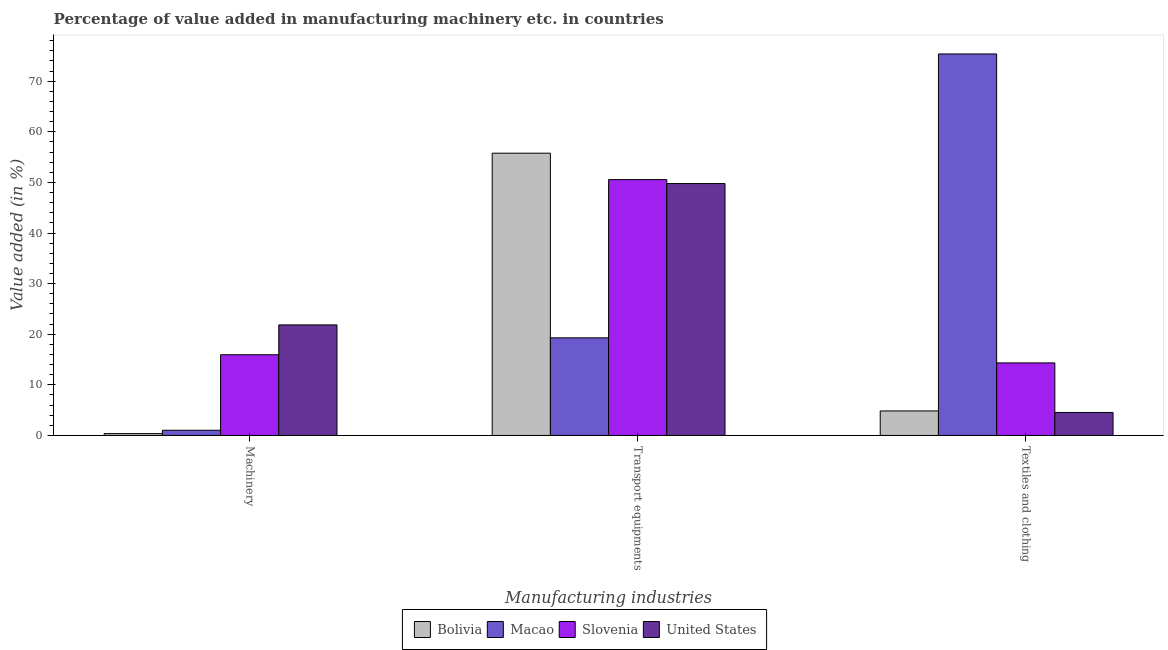How many different coloured bars are there?
Offer a very short reply. 4. How many groups of bars are there?
Your answer should be compact. 3. What is the label of the 1st group of bars from the left?
Your answer should be very brief. Machinery. What is the value added in manufacturing transport equipments in Macao?
Provide a short and direct response. 19.28. Across all countries, what is the maximum value added in manufacturing machinery?
Your response must be concise. 21.84. Across all countries, what is the minimum value added in manufacturing machinery?
Offer a terse response. 0.36. In which country was the value added in manufacturing textile and clothing maximum?
Offer a very short reply. Macao. In which country was the value added in manufacturing transport equipments minimum?
Give a very brief answer. Macao. What is the total value added in manufacturing transport equipments in the graph?
Provide a short and direct response. 175.39. What is the difference between the value added in manufacturing machinery in United States and that in Macao?
Give a very brief answer. 20.81. What is the difference between the value added in manufacturing transport equipments in United States and the value added in manufacturing textile and clothing in Macao?
Keep it short and to the point. -25.61. What is the average value added in manufacturing textile and clothing per country?
Ensure brevity in your answer.  24.78. What is the difference between the value added in manufacturing machinery and value added in manufacturing transport equipments in Macao?
Your response must be concise. -18.26. In how many countries, is the value added in manufacturing textile and clothing greater than 54 %?
Your answer should be compact. 1. What is the ratio of the value added in manufacturing transport equipments in Bolivia to that in Slovenia?
Ensure brevity in your answer.  1.1. Is the difference between the value added in manufacturing machinery in Bolivia and United States greater than the difference between the value added in manufacturing textile and clothing in Bolivia and United States?
Your response must be concise. No. What is the difference between the highest and the second highest value added in manufacturing machinery?
Keep it short and to the point. 5.9. What is the difference between the highest and the lowest value added in manufacturing machinery?
Offer a very short reply. 21.48. Is the sum of the value added in manufacturing textile and clothing in Slovenia and United States greater than the maximum value added in manufacturing machinery across all countries?
Make the answer very short. No. What does the 3rd bar from the left in Textiles and clothing represents?
Your answer should be very brief. Slovenia. What does the 3rd bar from the right in Machinery represents?
Provide a short and direct response. Macao. Is it the case that in every country, the sum of the value added in manufacturing machinery and value added in manufacturing transport equipments is greater than the value added in manufacturing textile and clothing?
Offer a very short reply. No. How many bars are there?
Your answer should be compact. 12. Are all the bars in the graph horizontal?
Make the answer very short. No. What is the difference between two consecutive major ticks on the Y-axis?
Your response must be concise. 10. Are the values on the major ticks of Y-axis written in scientific E-notation?
Your response must be concise. No. Does the graph contain any zero values?
Your answer should be very brief. No. How many legend labels are there?
Make the answer very short. 4. What is the title of the graph?
Ensure brevity in your answer.  Percentage of value added in manufacturing machinery etc. in countries. What is the label or title of the X-axis?
Keep it short and to the point. Manufacturing industries. What is the label or title of the Y-axis?
Ensure brevity in your answer.  Value added (in %). What is the Value added (in %) in Bolivia in Machinery?
Give a very brief answer. 0.36. What is the Value added (in %) in Macao in Machinery?
Offer a very short reply. 1.03. What is the Value added (in %) of Slovenia in Machinery?
Ensure brevity in your answer.  15.94. What is the Value added (in %) of United States in Machinery?
Your answer should be compact. 21.84. What is the Value added (in %) in Bolivia in Transport equipments?
Offer a terse response. 55.77. What is the Value added (in %) in Macao in Transport equipments?
Provide a succinct answer. 19.28. What is the Value added (in %) in Slovenia in Transport equipments?
Your response must be concise. 50.55. What is the Value added (in %) in United States in Transport equipments?
Keep it short and to the point. 49.77. What is the Value added (in %) in Bolivia in Textiles and clothing?
Your answer should be compact. 4.84. What is the Value added (in %) in Macao in Textiles and clothing?
Give a very brief answer. 75.38. What is the Value added (in %) of Slovenia in Textiles and clothing?
Give a very brief answer. 14.33. What is the Value added (in %) in United States in Textiles and clothing?
Offer a very short reply. 4.54. Across all Manufacturing industries, what is the maximum Value added (in %) in Bolivia?
Your response must be concise. 55.77. Across all Manufacturing industries, what is the maximum Value added (in %) of Macao?
Provide a short and direct response. 75.38. Across all Manufacturing industries, what is the maximum Value added (in %) in Slovenia?
Provide a succinct answer. 50.55. Across all Manufacturing industries, what is the maximum Value added (in %) in United States?
Your response must be concise. 49.77. Across all Manufacturing industries, what is the minimum Value added (in %) of Bolivia?
Offer a terse response. 0.36. Across all Manufacturing industries, what is the minimum Value added (in %) in Macao?
Ensure brevity in your answer.  1.03. Across all Manufacturing industries, what is the minimum Value added (in %) of Slovenia?
Your response must be concise. 14.33. Across all Manufacturing industries, what is the minimum Value added (in %) of United States?
Keep it short and to the point. 4.54. What is the total Value added (in %) in Bolivia in the graph?
Give a very brief answer. 60.98. What is the total Value added (in %) of Macao in the graph?
Provide a succinct answer. 95.7. What is the total Value added (in %) of Slovenia in the graph?
Give a very brief answer. 80.83. What is the total Value added (in %) in United States in the graph?
Your answer should be very brief. 76.16. What is the difference between the Value added (in %) of Bolivia in Machinery and that in Transport equipments?
Provide a succinct answer. -55.41. What is the difference between the Value added (in %) of Macao in Machinery and that in Transport equipments?
Provide a short and direct response. -18.26. What is the difference between the Value added (in %) in Slovenia in Machinery and that in Transport equipments?
Give a very brief answer. -34.61. What is the difference between the Value added (in %) of United States in Machinery and that in Transport equipments?
Keep it short and to the point. -27.93. What is the difference between the Value added (in %) of Bolivia in Machinery and that in Textiles and clothing?
Keep it short and to the point. -4.48. What is the difference between the Value added (in %) of Macao in Machinery and that in Textiles and clothing?
Give a very brief answer. -74.36. What is the difference between the Value added (in %) of Slovenia in Machinery and that in Textiles and clothing?
Provide a short and direct response. 1.61. What is the difference between the Value added (in %) in United States in Machinery and that in Textiles and clothing?
Ensure brevity in your answer.  17.3. What is the difference between the Value added (in %) of Bolivia in Transport equipments and that in Textiles and clothing?
Provide a short and direct response. 50.93. What is the difference between the Value added (in %) of Macao in Transport equipments and that in Textiles and clothing?
Provide a succinct answer. -56.1. What is the difference between the Value added (in %) of Slovenia in Transport equipments and that in Textiles and clothing?
Make the answer very short. 36.22. What is the difference between the Value added (in %) of United States in Transport equipments and that in Textiles and clothing?
Ensure brevity in your answer.  45.23. What is the difference between the Value added (in %) of Bolivia in Machinery and the Value added (in %) of Macao in Transport equipments?
Provide a succinct answer. -18.92. What is the difference between the Value added (in %) in Bolivia in Machinery and the Value added (in %) in Slovenia in Transport equipments?
Offer a very short reply. -50.19. What is the difference between the Value added (in %) of Bolivia in Machinery and the Value added (in %) of United States in Transport equipments?
Offer a terse response. -49.41. What is the difference between the Value added (in %) of Macao in Machinery and the Value added (in %) of Slovenia in Transport equipments?
Make the answer very short. -49.53. What is the difference between the Value added (in %) of Macao in Machinery and the Value added (in %) of United States in Transport equipments?
Offer a very short reply. -48.75. What is the difference between the Value added (in %) in Slovenia in Machinery and the Value added (in %) in United States in Transport equipments?
Offer a terse response. -33.83. What is the difference between the Value added (in %) of Bolivia in Machinery and the Value added (in %) of Macao in Textiles and clothing?
Provide a succinct answer. -75.02. What is the difference between the Value added (in %) in Bolivia in Machinery and the Value added (in %) in Slovenia in Textiles and clothing?
Provide a short and direct response. -13.97. What is the difference between the Value added (in %) in Bolivia in Machinery and the Value added (in %) in United States in Textiles and clothing?
Your answer should be compact. -4.18. What is the difference between the Value added (in %) of Macao in Machinery and the Value added (in %) of Slovenia in Textiles and clothing?
Offer a terse response. -13.31. What is the difference between the Value added (in %) of Macao in Machinery and the Value added (in %) of United States in Textiles and clothing?
Offer a terse response. -3.52. What is the difference between the Value added (in %) in Slovenia in Machinery and the Value added (in %) in United States in Textiles and clothing?
Your answer should be compact. 11.4. What is the difference between the Value added (in %) of Bolivia in Transport equipments and the Value added (in %) of Macao in Textiles and clothing?
Your answer should be very brief. -19.61. What is the difference between the Value added (in %) in Bolivia in Transport equipments and the Value added (in %) in Slovenia in Textiles and clothing?
Your answer should be compact. 41.44. What is the difference between the Value added (in %) of Bolivia in Transport equipments and the Value added (in %) of United States in Textiles and clothing?
Keep it short and to the point. 51.23. What is the difference between the Value added (in %) in Macao in Transport equipments and the Value added (in %) in Slovenia in Textiles and clothing?
Your response must be concise. 4.95. What is the difference between the Value added (in %) of Macao in Transport equipments and the Value added (in %) of United States in Textiles and clothing?
Provide a succinct answer. 14.74. What is the difference between the Value added (in %) of Slovenia in Transport equipments and the Value added (in %) of United States in Textiles and clothing?
Your response must be concise. 46.01. What is the average Value added (in %) in Bolivia per Manufacturing industries?
Offer a terse response. 20.33. What is the average Value added (in %) of Macao per Manufacturing industries?
Offer a very short reply. 31.9. What is the average Value added (in %) of Slovenia per Manufacturing industries?
Provide a short and direct response. 26.94. What is the average Value added (in %) in United States per Manufacturing industries?
Ensure brevity in your answer.  25.39. What is the difference between the Value added (in %) of Bolivia and Value added (in %) of Macao in Machinery?
Provide a short and direct response. -0.66. What is the difference between the Value added (in %) in Bolivia and Value added (in %) in Slovenia in Machinery?
Provide a succinct answer. -15.58. What is the difference between the Value added (in %) in Bolivia and Value added (in %) in United States in Machinery?
Make the answer very short. -21.48. What is the difference between the Value added (in %) in Macao and Value added (in %) in Slovenia in Machinery?
Make the answer very short. -14.92. What is the difference between the Value added (in %) of Macao and Value added (in %) of United States in Machinery?
Give a very brief answer. -20.81. What is the difference between the Value added (in %) of Slovenia and Value added (in %) of United States in Machinery?
Make the answer very short. -5.9. What is the difference between the Value added (in %) in Bolivia and Value added (in %) in Macao in Transport equipments?
Give a very brief answer. 36.49. What is the difference between the Value added (in %) in Bolivia and Value added (in %) in Slovenia in Transport equipments?
Your answer should be very brief. 5.22. What is the difference between the Value added (in %) of Bolivia and Value added (in %) of United States in Transport equipments?
Your response must be concise. 6. What is the difference between the Value added (in %) of Macao and Value added (in %) of Slovenia in Transport equipments?
Your answer should be compact. -31.27. What is the difference between the Value added (in %) in Macao and Value added (in %) in United States in Transport equipments?
Make the answer very short. -30.49. What is the difference between the Value added (in %) in Slovenia and Value added (in %) in United States in Transport equipments?
Make the answer very short. 0.78. What is the difference between the Value added (in %) of Bolivia and Value added (in %) of Macao in Textiles and clothing?
Provide a succinct answer. -70.54. What is the difference between the Value added (in %) of Bolivia and Value added (in %) of Slovenia in Textiles and clothing?
Offer a very short reply. -9.49. What is the difference between the Value added (in %) in Bolivia and Value added (in %) in United States in Textiles and clothing?
Your response must be concise. 0.3. What is the difference between the Value added (in %) in Macao and Value added (in %) in Slovenia in Textiles and clothing?
Your answer should be very brief. 61.05. What is the difference between the Value added (in %) of Macao and Value added (in %) of United States in Textiles and clothing?
Provide a short and direct response. 70.84. What is the difference between the Value added (in %) of Slovenia and Value added (in %) of United States in Textiles and clothing?
Make the answer very short. 9.79. What is the ratio of the Value added (in %) in Bolivia in Machinery to that in Transport equipments?
Your answer should be very brief. 0.01. What is the ratio of the Value added (in %) in Macao in Machinery to that in Transport equipments?
Provide a short and direct response. 0.05. What is the ratio of the Value added (in %) in Slovenia in Machinery to that in Transport equipments?
Your response must be concise. 0.32. What is the ratio of the Value added (in %) of United States in Machinery to that in Transport equipments?
Your response must be concise. 0.44. What is the ratio of the Value added (in %) in Bolivia in Machinery to that in Textiles and clothing?
Offer a very short reply. 0.07. What is the ratio of the Value added (in %) in Macao in Machinery to that in Textiles and clothing?
Your answer should be very brief. 0.01. What is the ratio of the Value added (in %) of Slovenia in Machinery to that in Textiles and clothing?
Provide a short and direct response. 1.11. What is the ratio of the Value added (in %) of United States in Machinery to that in Textiles and clothing?
Provide a short and direct response. 4.81. What is the ratio of the Value added (in %) of Bolivia in Transport equipments to that in Textiles and clothing?
Offer a terse response. 11.52. What is the ratio of the Value added (in %) in Macao in Transport equipments to that in Textiles and clothing?
Your answer should be very brief. 0.26. What is the ratio of the Value added (in %) in Slovenia in Transport equipments to that in Textiles and clothing?
Ensure brevity in your answer.  3.53. What is the ratio of the Value added (in %) in United States in Transport equipments to that in Textiles and clothing?
Give a very brief answer. 10.96. What is the difference between the highest and the second highest Value added (in %) of Bolivia?
Keep it short and to the point. 50.93. What is the difference between the highest and the second highest Value added (in %) in Macao?
Provide a short and direct response. 56.1. What is the difference between the highest and the second highest Value added (in %) in Slovenia?
Your answer should be compact. 34.61. What is the difference between the highest and the second highest Value added (in %) in United States?
Provide a succinct answer. 27.93. What is the difference between the highest and the lowest Value added (in %) of Bolivia?
Give a very brief answer. 55.41. What is the difference between the highest and the lowest Value added (in %) of Macao?
Your response must be concise. 74.36. What is the difference between the highest and the lowest Value added (in %) in Slovenia?
Offer a terse response. 36.22. What is the difference between the highest and the lowest Value added (in %) of United States?
Offer a very short reply. 45.23. 